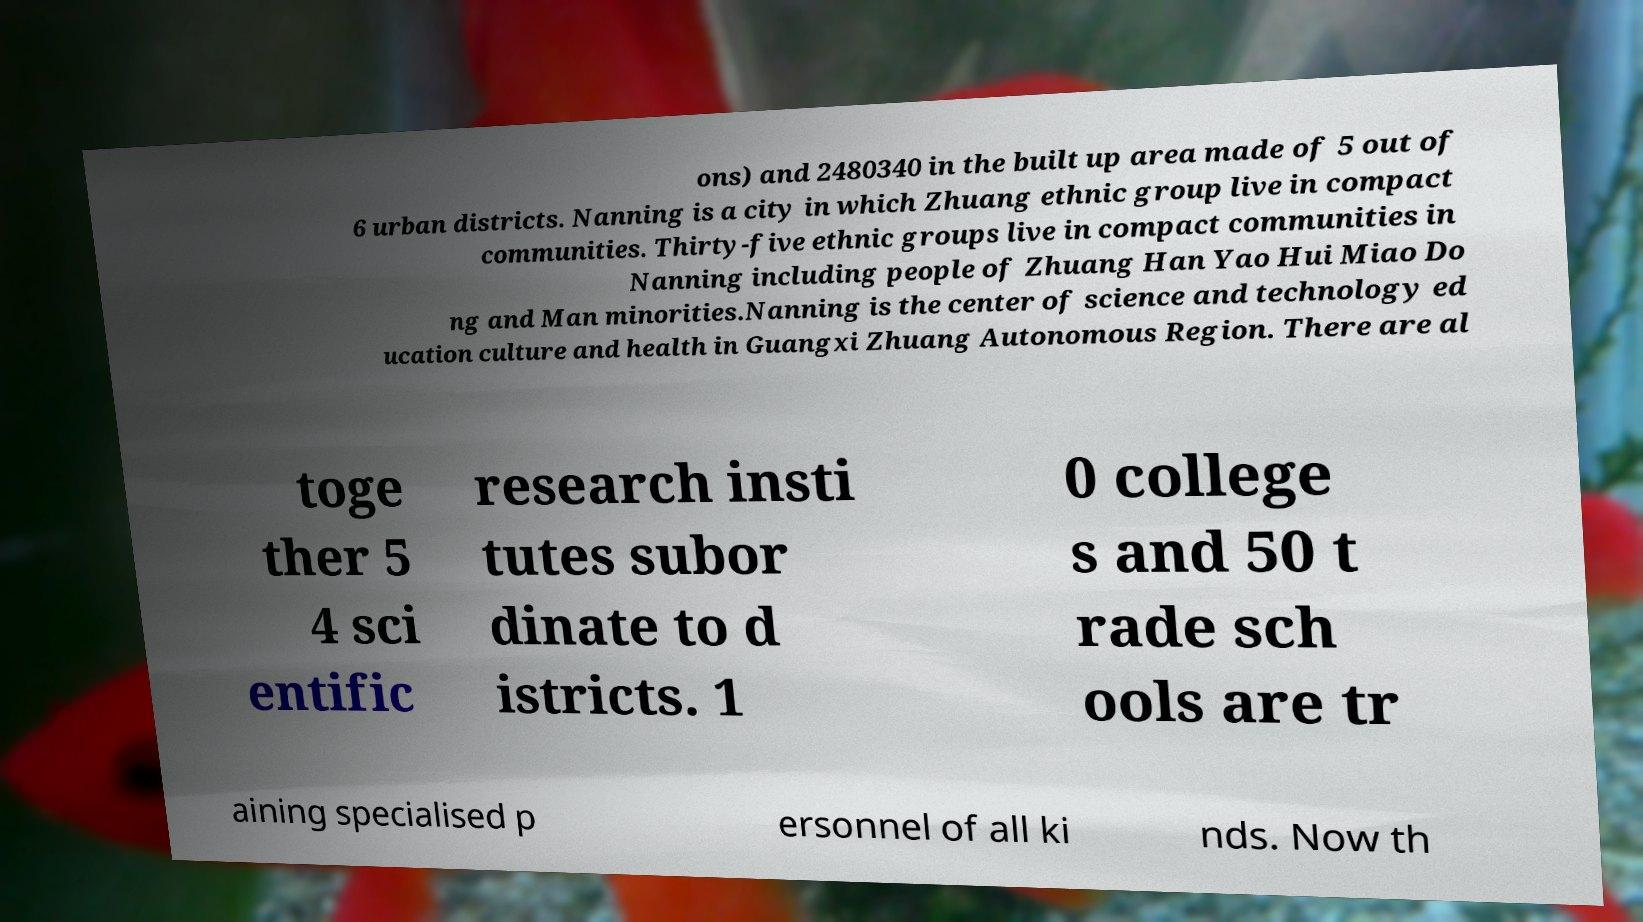Please read and relay the text visible in this image. What does it say? ons) and 2480340 in the built up area made of 5 out of 6 urban districts. Nanning is a city in which Zhuang ethnic group live in compact communities. Thirty-five ethnic groups live in compact communities in Nanning including people of Zhuang Han Yao Hui Miao Do ng and Man minorities.Nanning is the center of science and technology ed ucation culture and health in Guangxi Zhuang Autonomous Region. There are al toge ther 5 4 sci entific research insti tutes subor dinate to d istricts. 1 0 college s and 50 t rade sch ools are tr aining specialised p ersonnel of all ki nds. Now th 